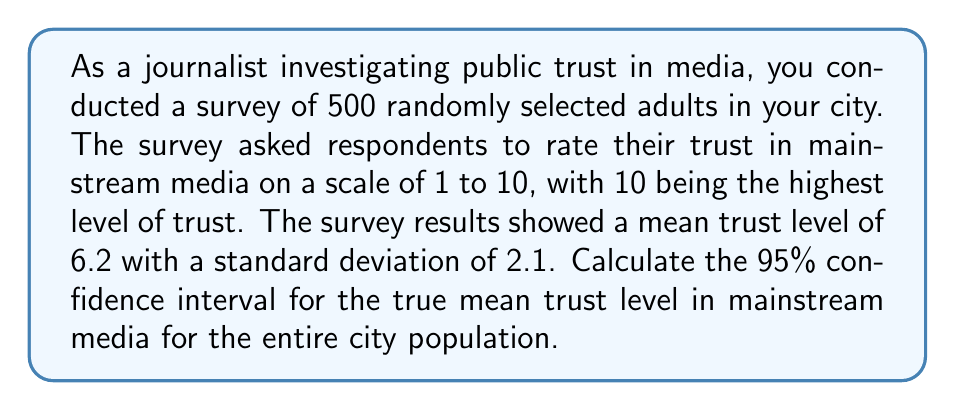Show me your answer to this math problem. To calculate the confidence interval, we'll use the formula:

$$ \text{CI} = \bar{x} \pm t_{\alpha/2} \cdot \frac{s}{\sqrt{n}} $$

Where:
$\bar{x}$ = sample mean
$t_{\alpha/2}$ = t-value for 95% confidence level
$s$ = sample standard deviation
$n$ = sample size

Step 1: Identify the known values
$\bar{x} = 6.2$
$s = 2.1$
$n = 500$
Confidence level = 95%

Step 2: Find the t-value
For a 95% confidence level and large sample size (n > 30), we can use the z-score of 1.96 instead of a t-value.

Step 3: Calculate the margin of error
$$ \text{Margin of Error} = 1.96 \cdot \frac{2.1}{\sqrt{500}} = 0.1841 $$

Step 4: Calculate the confidence interval
Lower bound: $6.2 - 0.1841 = 6.0159$
Upper bound: $6.2 + 0.1841 = 6.3841$

Therefore, the 95% confidence interval is (6.0159, 6.3841).
Answer: The 95% confidence interval for the true mean trust level in mainstream media is (6.02, 6.38), rounded to two decimal places. 